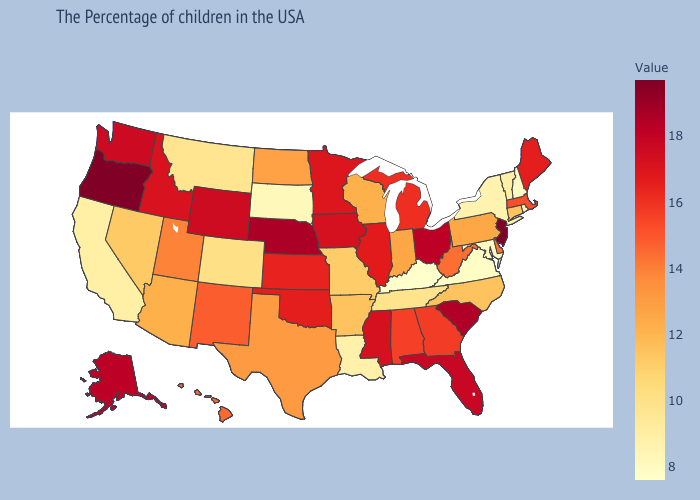Does the map have missing data?
Keep it brief. No. Among the states that border Wyoming , does Nebraska have the lowest value?
Quick response, please. No. Which states have the lowest value in the West?
Answer briefly. California. Among the states that border South Carolina , which have the highest value?
Give a very brief answer. Georgia. Does New Jersey have the highest value in the USA?
Quick response, please. Yes. Does Wisconsin have the lowest value in the MidWest?
Keep it brief. No. Which states have the lowest value in the South?
Give a very brief answer. Kentucky. Which states hav the highest value in the West?
Give a very brief answer. Oregon. Does Arkansas have a lower value than South Dakota?
Concise answer only. No. 